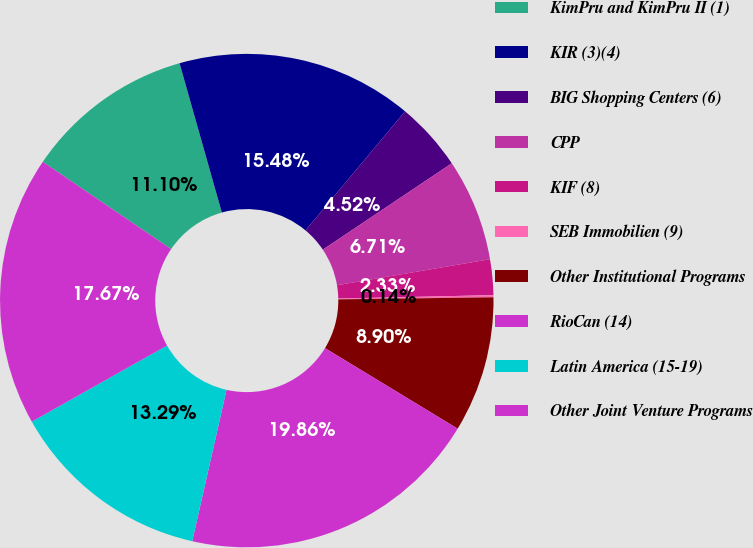Convert chart. <chart><loc_0><loc_0><loc_500><loc_500><pie_chart><fcel>KimPru and KimPru II (1)<fcel>KIR (3)(4)<fcel>BIG Shopping Centers (6)<fcel>CPP<fcel>KIF (8)<fcel>SEB Immobilien (9)<fcel>Other Institutional Programs<fcel>RioCan (14)<fcel>Latin America (15-19)<fcel>Other Joint Venture Programs<nl><fcel>11.1%<fcel>15.48%<fcel>4.52%<fcel>6.71%<fcel>2.33%<fcel>0.14%<fcel>8.9%<fcel>19.86%<fcel>13.29%<fcel>17.67%<nl></chart> 